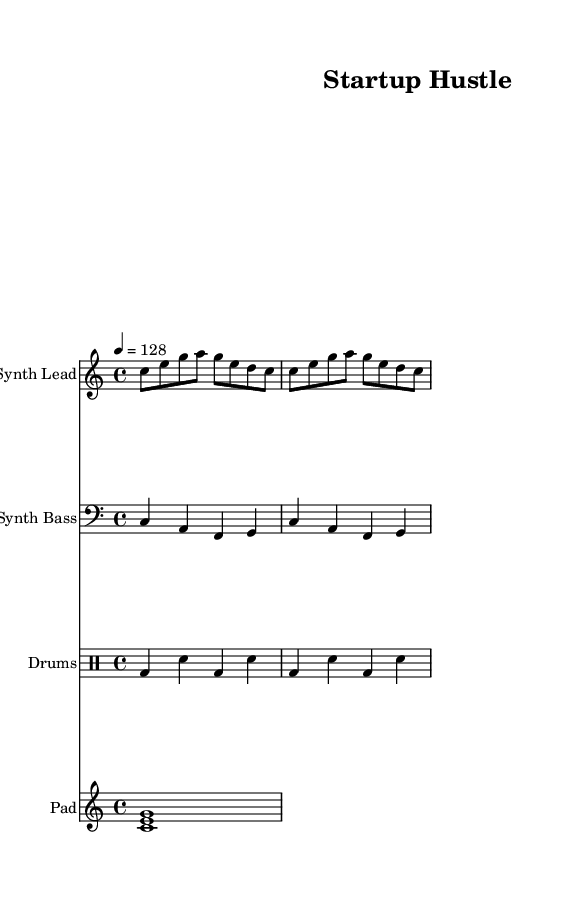what is the key signature of this music? The key signature is C major, which has no sharps or flats.
Answer: C major what is the time signature of this music? The time signature appears at the beginning of the score indicating 4 beats per measure, which is represented as 4/4.
Answer: 4/4 what is the tempo marking of this piece? The tempo marking indicates a metronome mark of 128 beats per minute, shown in the score as "4 = 128".
Answer: 128 how many distinct instruments are represented in the score? There are four distinct instruments represented, including the Synth Lead, Synth Bass, Drums, and Pad.
Answer: Four which instrument has the highest pitch range in the score? The Synth Lead plays in a higher pitch range, indicated by its placement in the treble staff compared to the bass staff and other instruments.
Answer: Synth Lead what rhythmic pattern is used in the drum part? The drum part consists of a pattern alternating between bass drum and snare drum, emphasizing beats 1 and 3 with the bass drum and 2 and 4 with the snare drum.
Answer: Bass and snare what type of chord is sustained in the Pad part? The Pad part features a C major chord, which is comprised of the notes C, E, and G played together in harmony.
Answer: C major chord 